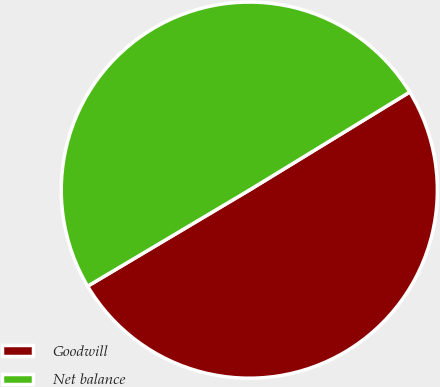<chart> <loc_0><loc_0><loc_500><loc_500><pie_chart><fcel>Goodwill<fcel>Net balance<nl><fcel>50.2%<fcel>49.8%<nl></chart> 